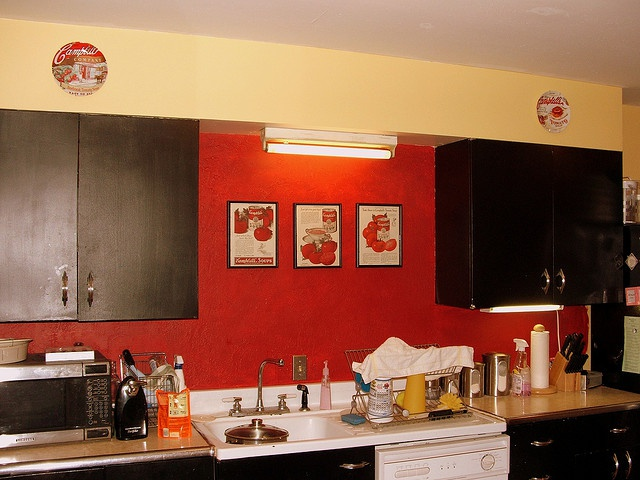Describe the objects in this image and their specific colors. I can see microwave in tan, black, lightgray, maroon, and gray tones, refrigerator in tan, black, gray, and olive tones, sink in tan, lightgray, and maroon tones, cup in tan, gray, and darkgray tones, and cup in tan and orange tones in this image. 